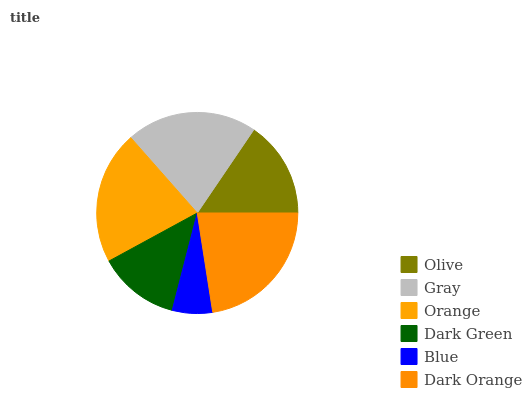Is Blue the minimum?
Answer yes or no. Yes. Is Dark Orange the maximum?
Answer yes or no. Yes. Is Gray the minimum?
Answer yes or no. No. Is Gray the maximum?
Answer yes or no. No. Is Gray greater than Olive?
Answer yes or no. Yes. Is Olive less than Gray?
Answer yes or no. Yes. Is Olive greater than Gray?
Answer yes or no. No. Is Gray less than Olive?
Answer yes or no. No. Is Gray the high median?
Answer yes or no. Yes. Is Olive the low median?
Answer yes or no. Yes. Is Orange the high median?
Answer yes or no. No. Is Dark Orange the low median?
Answer yes or no. No. 